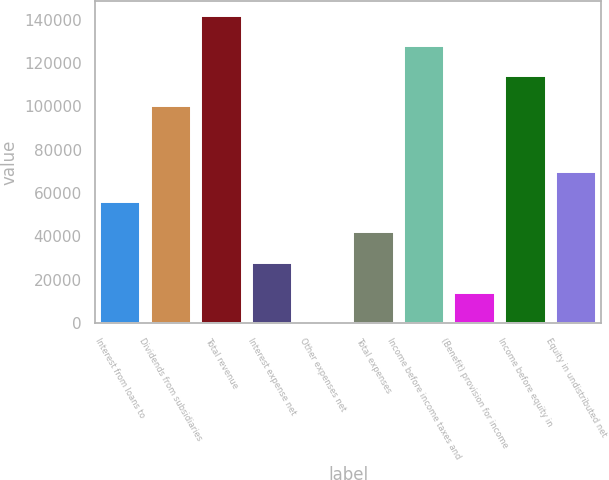Convert chart to OTSL. <chart><loc_0><loc_0><loc_500><loc_500><bar_chart><fcel>Interest from loans to<fcel>Dividends from subsidiaries<fcel>Total revenue<fcel>Interest expense net<fcel>Other expenses net<fcel>Total expenses<fcel>Income before income taxes and<fcel>(Benefit) provision for income<fcel>Income before equity in<fcel>Equity in undistributed net<nl><fcel>55582<fcel>100000<fcel>141582<fcel>27861<fcel>140<fcel>41721.5<fcel>127721<fcel>14000.5<fcel>113860<fcel>69442.5<nl></chart> 